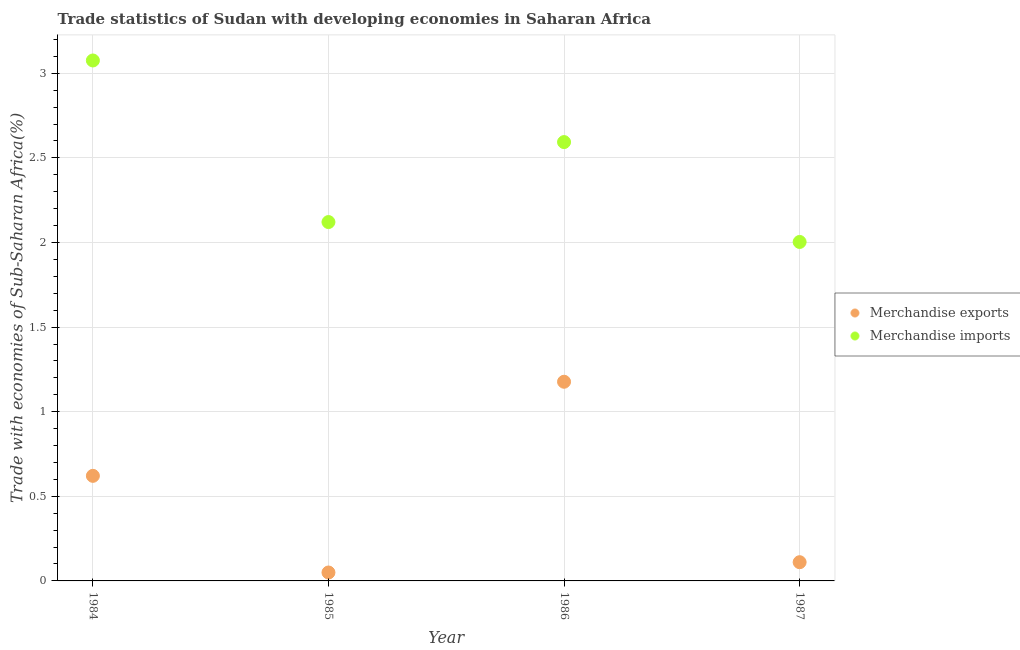How many different coloured dotlines are there?
Offer a very short reply. 2. Is the number of dotlines equal to the number of legend labels?
Your answer should be very brief. Yes. What is the merchandise exports in 1986?
Give a very brief answer. 1.18. Across all years, what is the maximum merchandise imports?
Make the answer very short. 3.08. Across all years, what is the minimum merchandise imports?
Provide a succinct answer. 2. In which year was the merchandise imports maximum?
Offer a terse response. 1984. In which year was the merchandise imports minimum?
Your answer should be compact. 1987. What is the total merchandise exports in the graph?
Offer a terse response. 1.96. What is the difference between the merchandise imports in 1984 and that in 1987?
Give a very brief answer. 1.07. What is the difference between the merchandise exports in 1985 and the merchandise imports in 1984?
Provide a succinct answer. -3.03. What is the average merchandise exports per year?
Offer a terse response. 0.49. In the year 1986, what is the difference between the merchandise exports and merchandise imports?
Offer a very short reply. -1.42. What is the ratio of the merchandise imports in 1984 to that in 1985?
Your response must be concise. 1.45. What is the difference between the highest and the second highest merchandise imports?
Your answer should be very brief. 0.48. What is the difference between the highest and the lowest merchandise exports?
Your response must be concise. 1.13. Is the merchandise exports strictly greater than the merchandise imports over the years?
Provide a succinct answer. No. Is the merchandise exports strictly less than the merchandise imports over the years?
Your response must be concise. Yes. How many dotlines are there?
Your answer should be very brief. 2. How many years are there in the graph?
Your response must be concise. 4. What is the difference between two consecutive major ticks on the Y-axis?
Offer a terse response. 0.5. Does the graph contain any zero values?
Give a very brief answer. No. Does the graph contain grids?
Give a very brief answer. Yes. How are the legend labels stacked?
Give a very brief answer. Vertical. What is the title of the graph?
Your answer should be very brief. Trade statistics of Sudan with developing economies in Saharan Africa. Does "Quality of trade" appear as one of the legend labels in the graph?
Make the answer very short. No. What is the label or title of the Y-axis?
Your response must be concise. Trade with economies of Sub-Saharan Africa(%). What is the Trade with economies of Sub-Saharan Africa(%) of Merchandise exports in 1984?
Your answer should be very brief. 0.62. What is the Trade with economies of Sub-Saharan Africa(%) of Merchandise imports in 1984?
Ensure brevity in your answer.  3.08. What is the Trade with economies of Sub-Saharan Africa(%) in Merchandise exports in 1985?
Give a very brief answer. 0.05. What is the Trade with economies of Sub-Saharan Africa(%) of Merchandise imports in 1985?
Offer a terse response. 2.12. What is the Trade with economies of Sub-Saharan Africa(%) in Merchandise exports in 1986?
Provide a succinct answer. 1.18. What is the Trade with economies of Sub-Saharan Africa(%) of Merchandise imports in 1986?
Your response must be concise. 2.59. What is the Trade with economies of Sub-Saharan Africa(%) of Merchandise exports in 1987?
Keep it short and to the point. 0.11. What is the Trade with economies of Sub-Saharan Africa(%) of Merchandise imports in 1987?
Keep it short and to the point. 2. Across all years, what is the maximum Trade with economies of Sub-Saharan Africa(%) in Merchandise exports?
Provide a short and direct response. 1.18. Across all years, what is the maximum Trade with economies of Sub-Saharan Africa(%) in Merchandise imports?
Offer a very short reply. 3.08. Across all years, what is the minimum Trade with economies of Sub-Saharan Africa(%) of Merchandise exports?
Offer a very short reply. 0.05. Across all years, what is the minimum Trade with economies of Sub-Saharan Africa(%) in Merchandise imports?
Provide a succinct answer. 2. What is the total Trade with economies of Sub-Saharan Africa(%) in Merchandise exports in the graph?
Provide a short and direct response. 1.96. What is the total Trade with economies of Sub-Saharan Africa(%) in Merchandise imports in the graph?
Give a very brief answer. 9.79. What is the difference between the Trade with economies of Sub-Saharan Africa(%) of Merchandise exports in 1984 and that in 1985?
Provide a short and direct response. 0.57. What is the difference between the Trade with economies of Sub-Saharan Africa(%) in Merchandise imports in 1984 and that in 1985?
Make the answer very short. 0.95. What is the difference between the Trade with economies of Sub-Saharan Africa(%) of Merchandise exports in 1984 and that in 1986?
Give a very brief answer. -0.56. What is the difference between the Trade with economies of Sub-Saharan Africa(%) of Merchandise imports in 1984 and that in 1986?
Provide a short and direct response. 0.48. What is the difference between the Trade with economies of Sub-Saharan Africa(%) of Merchandise exports in 1984 and that in 1987?
Your answer should be very brief. 0.51. What is the difference between the Trade with economies of Sub-Saharan Africa(%) of Merchandise imports in 1984 and that in 1987?
Offer a very short reply. 1.07. What is the difference between the Trade with economies of Sub-Saharan Africa(%) of Merchandise exports in 1985 and that in 1986?
Offer a terse response. -1.13. What is the difference between the Trade with economies of Sub-Saharan Africa(%) in Merchandise imports in 1985 and that in 1986?
Your response must be concise. -0.47. What is the difference between the Trade with economies of Sub-Saharan Africa(%) in Merchandise exports in 1985 and that in 1987?
Your response must be concise. -0.06. What is the difference between the Trade with economies of Sub-Saharan Africa(%) in Merchandise imports in 1985 and that in 1987?
Give a very brief answer. 0.12. What is the difference between the Trade with economies of Sub-Saharan Africa(%) in Merchandise exports in 1986 and that in 1987?
Give a very brief answer. 1.07. What is the difference between the Trade with economies of Sub-Saharan Africa(%) in Merchandise imports in 1986 and that in 1987?
Provide a succinct answer. 0.59. What is the difference between the Trade with economies of Sub-Saharan Africa(%) of Merchandise exports in 1984 and the Trade with economies of Sub-Saharan Africa(%) of Merchandise imports in 1985?
Provide a succinct answer. -1.5. What is the difference between the Trade with economies of Sub-Saharan Africa(%) of Merchandise exports in 1984 and the Trade with economies of Sub-Saharan Africa(%) of Merchandise imports in 1986?
Ensure brevity in your answer.  -1.97. What is the difference between the Trade with economies of Sub-Saharan Africa(%) in Merchandise exports in 1984 and the Trade with economies of Sub-Saharan Africa(%) in Merchandise imports in 1987?
Keep it short and to the point. -1.38. What is the difference between the Trade with economies of Sub-Saharan Africa(%) of Merchandise exports in 1985 and the Trade with economies of Sub-Saharan Africa(%) of Merchandise imports in 1986?
Make the answer very short. -2.54. What is the difference between the Trade with economies of Sub-Saharan Africa(%) of Merchandise exports in 1985 and the Trade with economies of Sub-Saharan Africa(%) of Merchandise imports in 1987?
Offer a terse response. -1.95. What is the difference between the Trade with economies of Sub-Saharan Africa(%) in Merchandise exports in 1986 and the Trade with economies of Sub-Saharan Africa(%) in Merchandise imports in 1987?
Your answer should be compact. -0.83. What is the average Trade with economies of Sub-Saharan Africa(%) of Merchandise exports per year?
Your answer should be very brief. 0.49. What is the average Trade with economies of Sub-Saharan Africa(%) of Merchandise imports per year?
Your response must be concise. 2.45. In the year 1984, what is the difference between the Trade with economies of Sub-Saharan Africa(%) of Merchandise exports and Trade with economies of Sub-Saharan Africa(%) of Merchandise imports?
Ensure brevity in your answer.  -2.45. In the year 1985, what is the difference between the Trade with economies of Sub-Saharan Africa(%) of Merchandise exports and Trade with economies of Sub-Saharan Africa(%) of Merchandise imports?
Provide a short and direct response. -2.07. In the year 1986, what is the difference between the Trade with economies of Sub-Saharan Africa(%) of Merchandise exports and Trade with economies of Sub-Saharan Africa(%) of Merchandise imports?
Your answer should be very brief. -1.42. In the year 1987, what is the difference between the Trade with economies of Sub-Saharan Africa(%) in Merchandise exports and Trade with economies of Sub-Saharan Africa(%) in Merchandise imports?
Ensure brevity in your answer.  -1.89. What is the ratio of the Trade with economies of Sub-Saharan Africa(%) in Merchandise exports in 1984 to that in 1985?
Make the answer very short. 12.47. What is the ratio of the Trade with economies of Sub-Saharan Africa(%) of Merchandise imports in 1984 to that in 1985?
Your answer should be compact. 1.45. What is the ratio of the Trade with economies of Sub-Saharan Africa(%) of Merchandise exports in 1984 to that in 1986?
Offer a terse response. 0.53. What is the ratio of the Trade with economies of Sub-Saharan Africa(%) in Merchandise imports in 1984 to that in 1986?
Provide a short and direct response. 1.19. What is the ratio of the Trade with economies of Sub-Saharan Africa(%) of Merchandise exports in 1984 to that in 1987?
Your answer should be compact. 5.61. What is the ratio of the Trade with economies of Sub-Saharan Africa(%) in Merchandise imports in 1984 to that in 1987?
Your response must be concise. 1.54. What is the ratio of the Trade with economies of Sub-Saharan Africa(%) in Merchandise exports in 1985 to that in 1986?
Your response must be concise. 0.04. What is the ratio of the Trade with economies of Sub-Saharan Africa(%) of Merchandise imports in 1985 to that in 1986?
Provide a succinct answer. 0.82. What is the ratio of the Trade with economies of Sub-Saharan Africa(%) in Merchandise exports in 1985 to that in 1987?
Keep it short and to the point. 0.45. What is the ratio of the Trade with economies of Sub-Saharan Africa(%) in Merchandise imports in 1985 to that in 1987?
Give a very brief answer. 1.06. What is the ratio of the Trade with economies of Sub-Saharan Africa(%) in Merchandise exports in 1986 to that in 1987?
Ensure brevity in your answer.  10.64. What is the ratio of the Trade with economies of Sub-Saharan Africa(%) of Merchandise imports in 1986 to that in 1987?
Your response must be concise. 1.29. What is the difference between the highest and the second highest Trade with economies of Sub-Saharan Africa(%) in Merchandise exports?
Offer a terse response. 0.56. What is the difference between the highest and the second highest Trade with economies of Sub-Saharan Africa(%) of Merchandise imports?
Provide a succinct answer. 0.48. What is the difference between the highest and the lowest Trade with economies of Sub-Saharan Africa(%) in Merchandise exports?
Give a very brief answer. 1.13. What is the difference between the highest and the lowest Trade with economies of Sub-Saharan Africa(%) of Merchandise imports?
Keep it short and to the point. 1.07. 